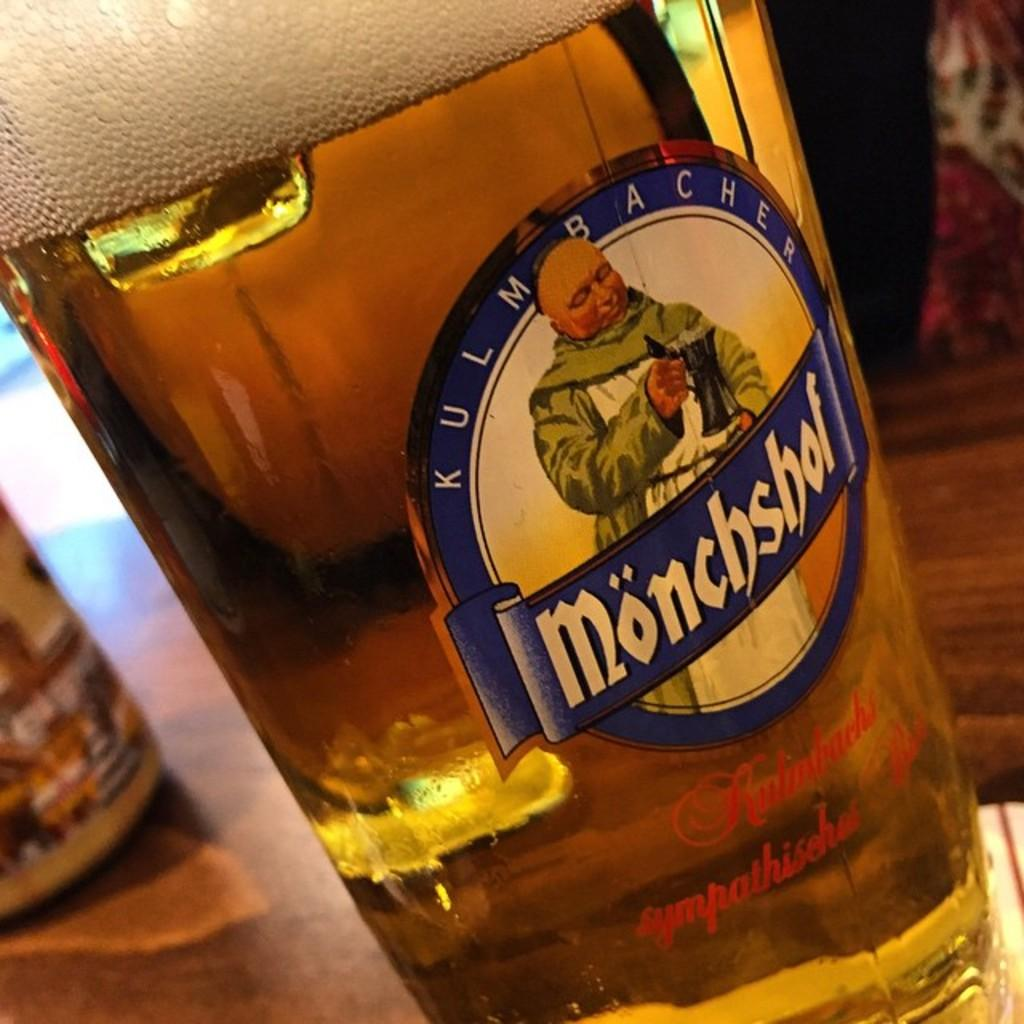What object can be seen in the image? There is a bottle in the image. How much wealth does the bottle represent in the image? The image does not convey any information about wealth, and the bottle is not associated with any monetary value in the image. 